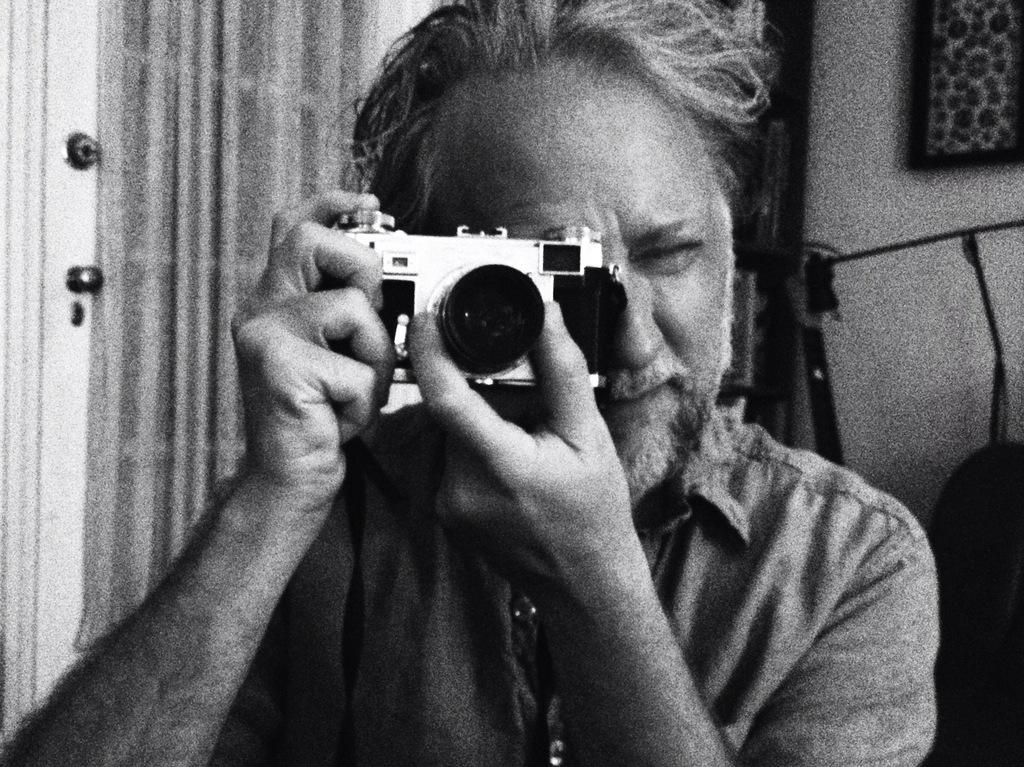In one or two sentences, can you explain what this image depicts? A man is taking picture with a camera in his hand. There is a door in the background. There is a photo frame on the wall. 